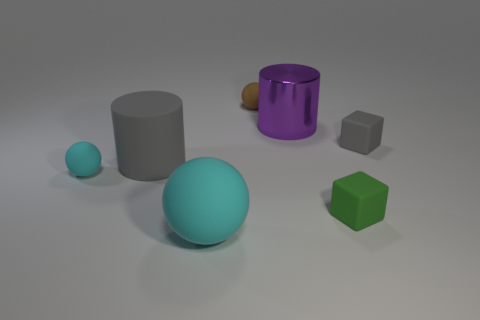What is the size of the purple shiny cylinder?
Your response must be concise. Large. How many matte cylinders have the same size as the metal cylinder?
Offer a terse response. 1. Are there fewer gray objects to the right of the matte cylinder than large cyan rubber objects on the right side of the tiny gray matte object?
Your response must be concise. No. What is the size of the purple metallic thing that is behind the cyan matte object that is to the left of the cylinder left of the brown ball?
Your response must be concise. Large. There is a ball that is both to the right of the small cyan matte object and in front of the large metallic cylinder; what is its size?
Your response must be concise. Large. What shape is the gray rubber object that is in front of the gray thing that is on the right side of the big cyan matte ball?
Ensure brevity in your answer.  Cylinder. Is there any other thing of the same color as the large metallic cylinder?
Ensure brevity in your answer.  No. There is a large rubber object in front of the small cyan rubber ball; what is its shape?
Ensure brevity in your answer.  Sphere. The tiny rubber thing that is both to the right of the shiny cylinder and on the left side of the gray rubber block has what shape?
Your answer should be very brief. Cube. How many gray things are either blocks or tiny rubber objects?
Your answer should be very brief. 1. 